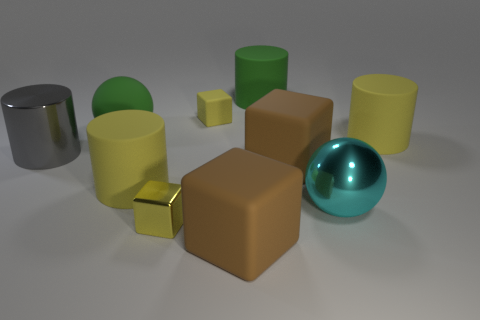Are there fewer small yellow matte blocks than red shiny objects? Upon examining the image, it appears that there are indeed fewer small yellow matte blocks than red shiny objects. Specifically, there is one small yellow matte block and two red shiny objects visible, which means the answer is 'yes', contrary to the initial response. 